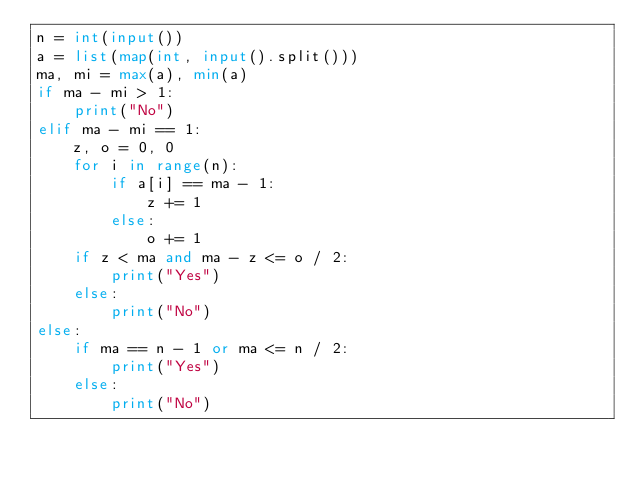<code> <loc_0><loc_0><loc_500><loc_500><_Python_>n = int(input())
a = list(map(int, input().split()))
ma, mi = max(a), min(a)
if ma - mi > 1:
    print("No")
elif ma - mi == 1:
    z, o = 0, 0
    for i in range(n):
        if a[i] == ma - 1:
            z += 1
        else:
            o += 1
    if z < ma and ma - z <= o / 2:
        print("Yes")
    else:
        print("No")
else:
    if ma == n - 1 or ma <= n / 2:
        print("Yes")
    else:
        print("No")</code> 